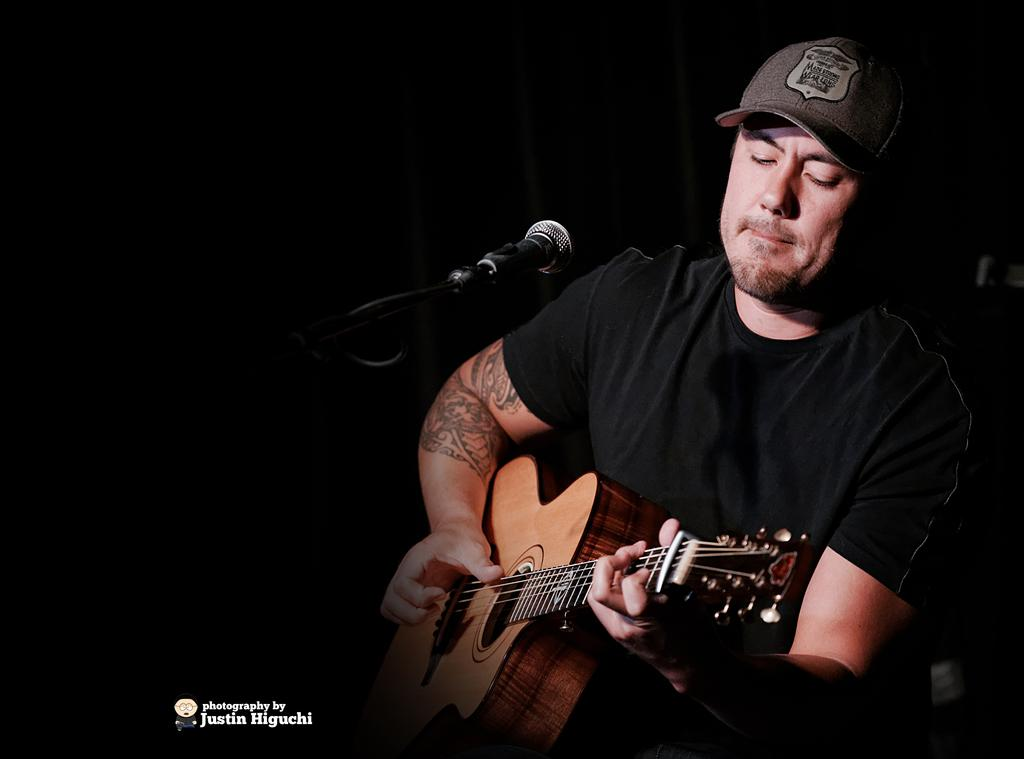What is the man wearing on his upper body in the image? The man is wearing a black t-shirt in the image. What type of headwear is the man wearing? The man is wearing a cap in the image. What is the man doing in the image? The man is playing a guitar in the image. What object is in front of the man? The man is in front of a microphone in the image. What is the color of the background in the image? The background is black in color. How many boats can be seen in the image? There are no boats present in the image. What achievement has the man recently accomplished, as depicted in the image? The image does not show any indication of the man's recent achievements. 